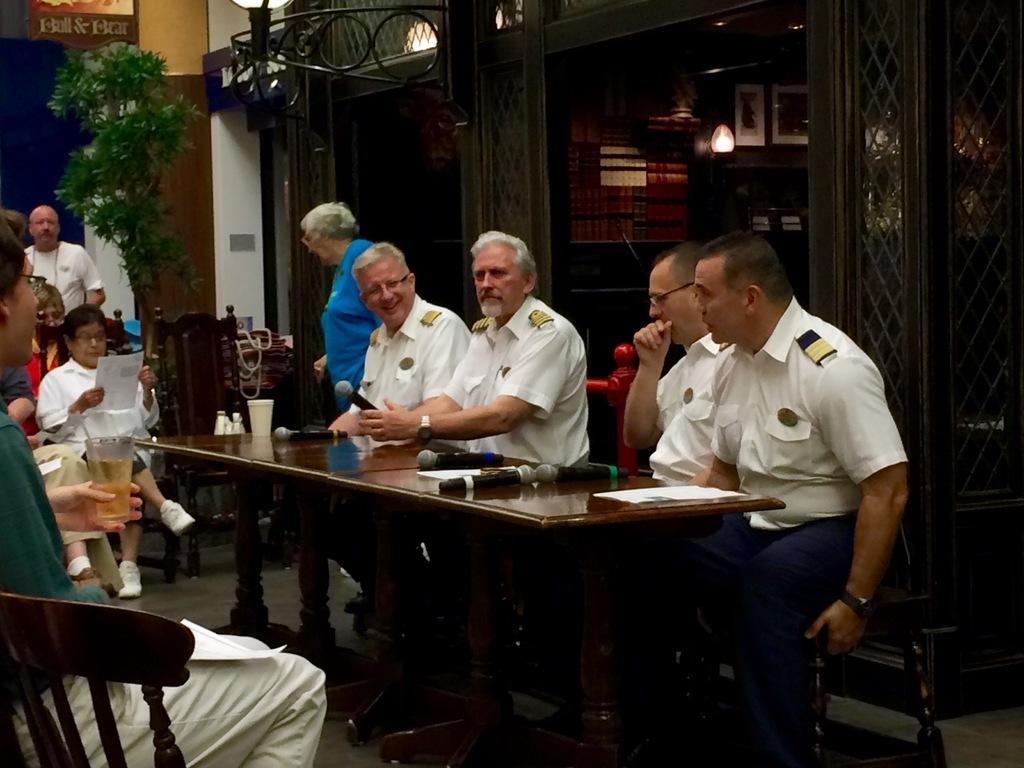Describe this image in one or two sentences. The person's wearing white shirts is sitting in chairs and there is a table in front of them and the table consists of mikes and papers and there group of people in front of them. 